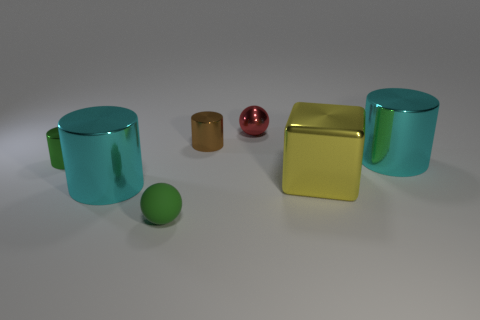Is the small red ball made of the same material as the cyan cylinder on the right side of the small green matte sphere?
Offer a terse response. Yes. There is a green object that is the same shape as the small brown metallic object; what is it made of?
Provide a succinct answer. Metal. Is there any other thing that has the same material as the tiny red thing?
Make the answer very short. Yes. Are there more green rubber balls that are on the right side of the tiny brown cylinder than green cylinders that are to the right of the yellow metallic block?
Offer a terse response. No. What is the shape of the yellow thing that is made of the same material as the red ball?
Make the answer very short. Cube. How many other objects are there of the same shape as the tiny red metallic thing?
Give a very brief answer. 1. There is a large shiny thing behind the small green metallic object; what is its shape?
Offer a very short reply. Cylinder. The metallic sphere is what color?
Your response must be concise. Red. What number of other objects are the same size as the brown object?
Offer a terse response. 3. What material is the red object on the right side of the green cylinder that is behind the tiny rubber ball?
Offer a very short reply. Metal. 